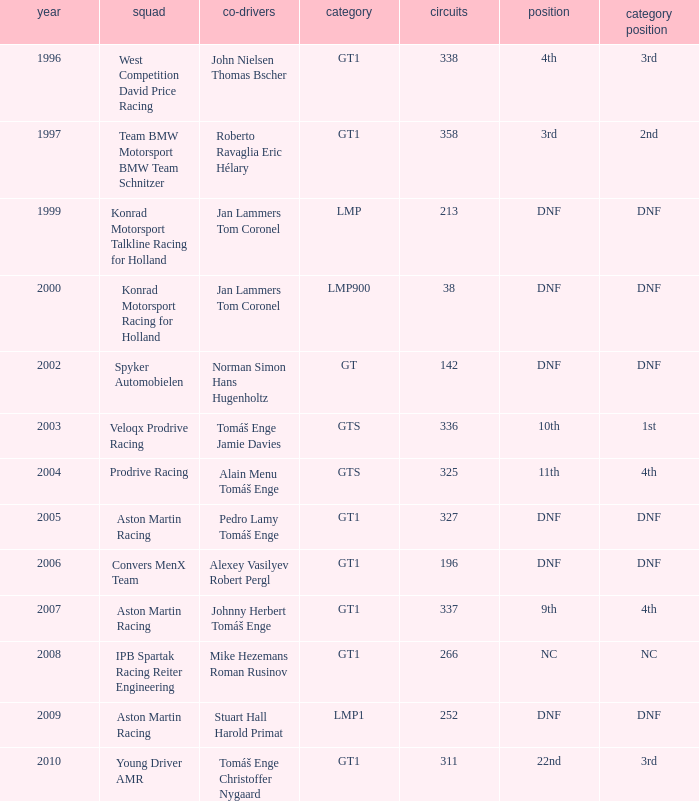Which team finished 3rd in class with 337 laps before 2008? West Competition David Price Racing. 